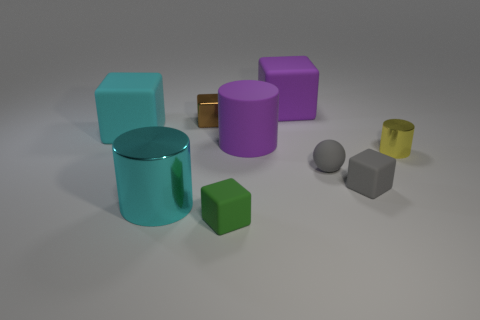Subtract all metal blocks. How many blocks are left? 4 Subtract 1 blocks. How many blocks are left? 4 Subtract all brown cubes. How many cubes are left? 4 Subtract all cyan blocks. Subtract all brown cylinders. How many blocks are left? 4 Subtract all balls. How many objects are left? 8 Subtract all large purple blocks. Subtract all brown blocks. How many objects are left? 7 Add 4 cyan cylinders. How many cyan cylinders are left? 5 Add 3 tiny yellow things. How many tiny yellow things exist? 4 Subtract 1 purple cylinders. How many objects are left? 8 